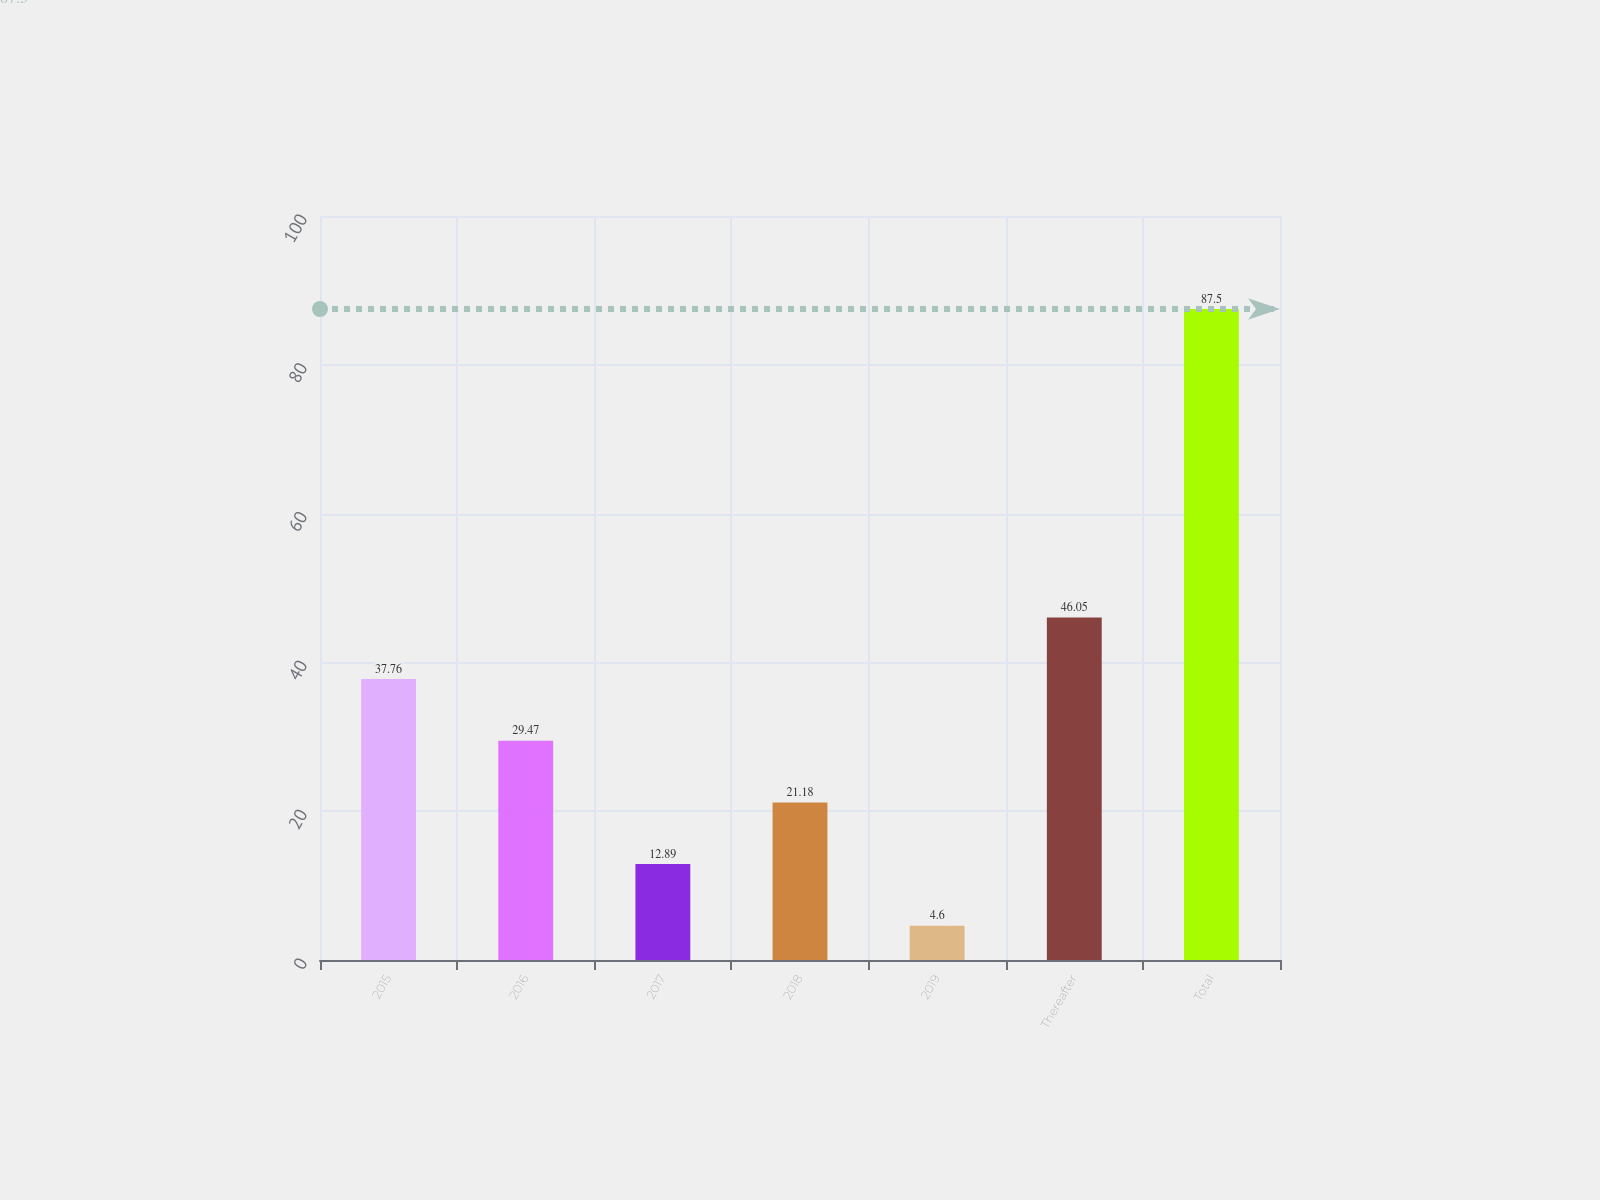Convert chart to OTSL. <chart><loc_0><loc_0><loc_500><loc_500><bar_chart><fcel>2015<fcel>2016<fcel>2017<fcel>2018<fcel>2019<fcel>Thereafter<fcel>Total<nl><fcel>37.76<fcel>29.47<fcel>12.89<fcel>21.18<fcel>4.6<fcel>46.05<fcel>87.5<nl></chart> 